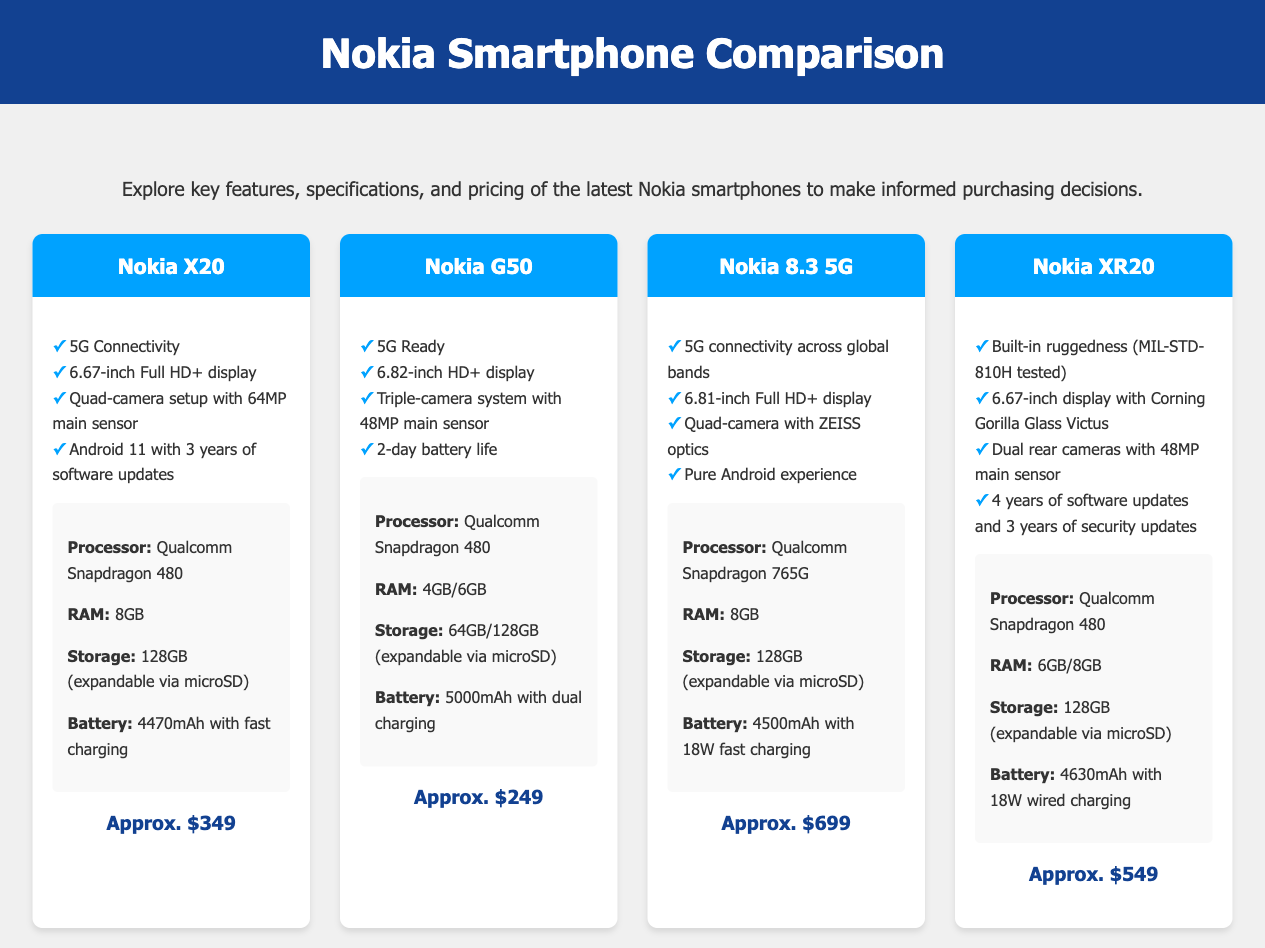What is the display size of Nokia X20? The display size is mentioned in the phone details for Nokia X20 as 6.67 inches Full HD+.
Answer: 6.67-inch What is the main camera resolution of Nokia G50? The main camera resolution for Nokia G50 is specified as 48MP in the triple-camera system.
Answer: 48MP How long is the battery life advertised for Nokia G50? The document states that Nokia G50 has a 2-day battery life, which is stated in its features.
Answer: 2-day Which Nokia model has ZEISS optics in its camera? The Nokia 8.3 5G is noted for having quad-camera with ZEISS optics in its features.
Answer: Nokia 8.3 5G What is the approximate price of Nokia XR20? The document lists the approximate price of Nokia XR20 as $549.
Answer: $549 How many years of software updates does Nokia X20 guarantee? The Nokia X20 provides 3 years of software updates, as mentioned in the features section.
Answer: 3 years Which processor is used in Nokia 8.3 5G? The processor listed for Nokia 8.3 5G is Qualcomm Snapdragon 765G, which can be found under specs.
Answer: Qualcomm Snapdragon 765G What is the storage capacity of Nokia G50? The document outlines that Nokia G50 offers storage options of 64GB and 128GB (expandable via microSD).
Answer: 64GB/128GB Which Nokia smartphone is MIL-STD-810H tested? The Nokia XR20 is specifically mentioned to be built with ruggedness and MIL-STD-810H tested in its features.
Answer: Nokia XR20 